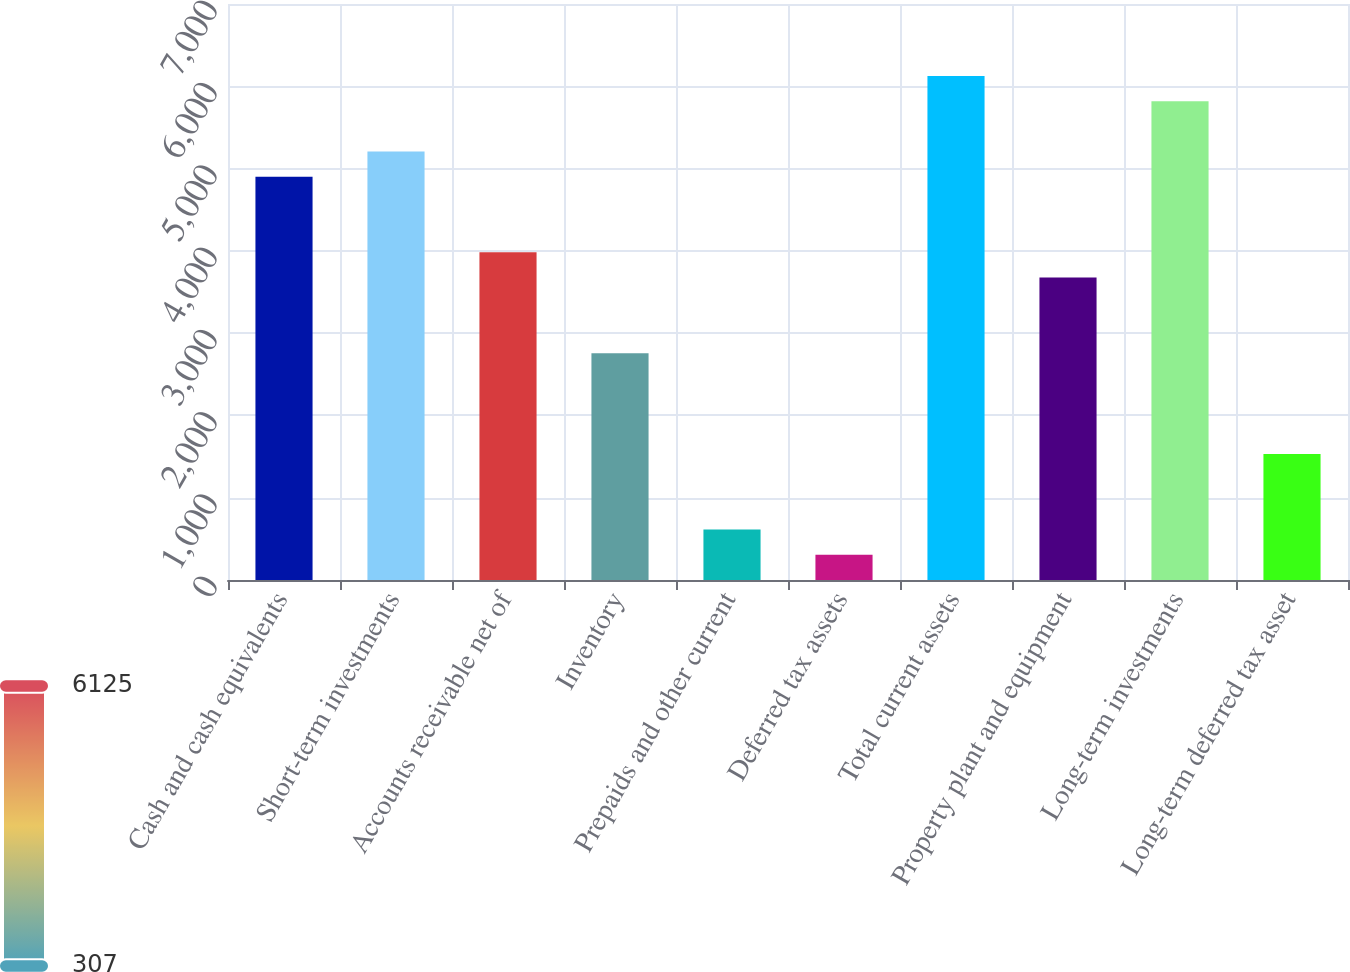<chart> <loc_0><loc_0><loc_500><loc_500><bar_chart><fcel>Cash and cash equivalents<fcel>Short-term investments<fcel>Accounts receivable net of<fcel>Inventory<fcel>Prepaids and other current<fcel>Deferred tax assets<fcel>Total current assets<fcel>Property plant and equipment<fcel>Long-term investments<fcel>Long-term deferred tax asset<nl><fcel>4900.42<fcel>5206.64<fcel>3981.76<fcel>2756.88<fcel>613.34<fcel>307.12<fcel>6125.3<fcel>3675.54<fcel>5819.08<fcel>1532<nl></chart> 